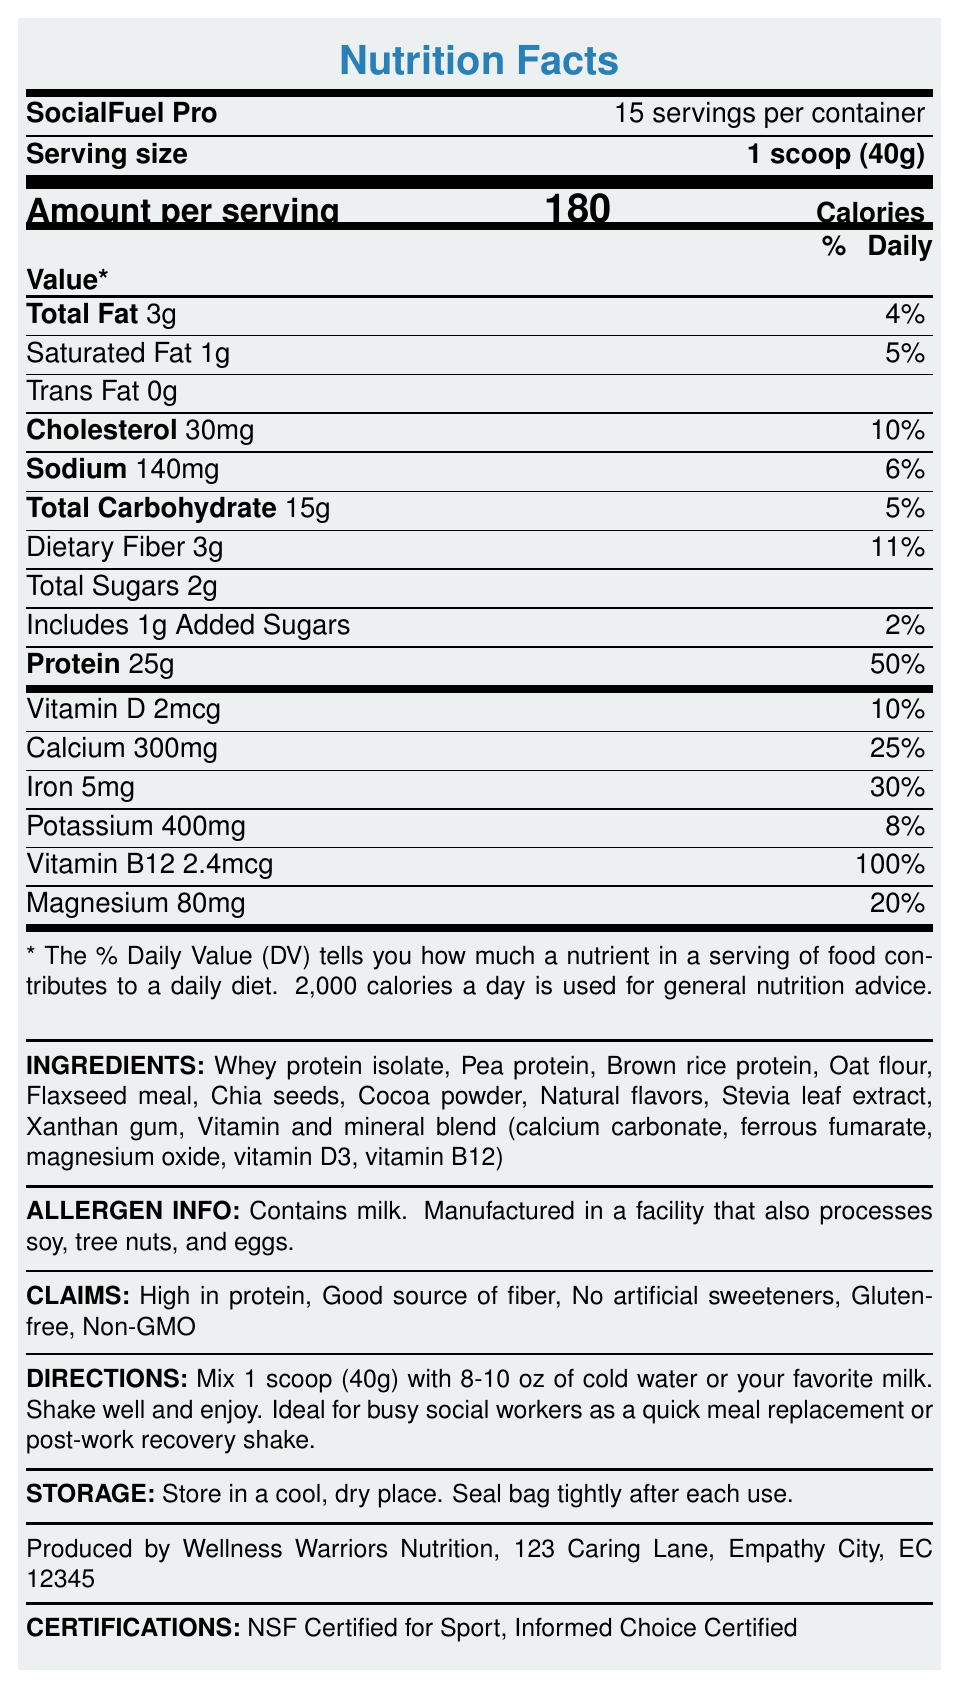What is the product name? The product name "SocialFuel Pro" is mentioned in the document under the heading "SocialFuel Pro."
Answer: SocialFuel Pro What is the serving size for this product? The serving size "1 scoop (40g)" is explicitly stated in the document.
Answer: 1 scoop (40g) How many calories are in one serving? The document lists "Calories: 180" in the section labeled "Amount per serving."
Answer: 180 What percentage of the daily value of protein is provided by one serving? The document states "Protein 25g" followed by "50%" under the "% Daily Value" column.
Answer: 50% List three proteins found in the ingredient list. The ingredients section lists "Whey protein isolate," "Pea protein," and "Brown rice protein" among other ingredients.
Answer: Whey protein isolate, Pea protein, Brown rice protein How many servings are there per container? The document mentions "15 servings per container" right beneath the product name.
Answer: 15 What is the amount of dietary fiber per serving? The document lists "Dietary Fiber 3g" under the section "Total Carbohydrate."
Answer: 3g Which vitamin in the product has the highest daily value percentage per serving? The document shows "Vitamin B12 2.4mcg" with "100%" daily value, which is the highest compared to other vitamins and minerals listed.
Answer: Vitamin B12 What are the allergens listed in the document? Contains milk. The allergens section of the document also mentions the product is manufactured in a facility that processes soy, tree nuts, and eggs.
Answer: Milk Which of the following claims does the product NOT make? A. High in protein B. Low in sodium C. Gluten-free D. Non-GMO The document lists claims including "High in protein," "Gluten-free," and "Non-GMO" but no claim about "Low in sodium."
Answer: B What mineral provides 30% of the daily value per serving? A. Calcium B. Iron C. Magnesium D. Potassium "Iron 5mg" is listed with "30%" daily value under the minerals section, while other minerals listed have different percentages.
Answer: B Is this product certified by NSF for Sport? The certifications section of the document mentions "NSF Certified for Sport."
Answer: Yes Summarize the main idea of the document. The document includes comprehensive nutritional information, ingredients, claims, and usage instructions for SocialFuel Pro, a high-protein meal replacement shake tailored for busy social workers.
Answer: The document provides the nutrition facts for a high-protein meal replacement shake called SocialFuel Pro. It details the serving size, number of servings per container, calories, macronutrient content, vitamins, and minerals, along with ingredient information, allergen info, product claims, directions for use, storage instructions, manufacturer info, and certifications. What is the specific percentage of daily value for calcium per serving? The document lists "Calcium 300mg" with a daily value of "25%."
Answer: 25% How many grams of total sugars are in one serving? The document mentions "Total Sugars 2g" under the total carbohydrate section.
Answer: 2g Who is the manufacturer of the product? The bottom of the document lists the manufacturer as "Wellness Warriors Nutrition."
Answer: Wellness Warriors Nutrition What is the vitamin and mineral blend included in the ingredients? The ingredient list includes a "Vitamin and mineral blend" specifying the components: calcium carbonate, ferrous fumarate, magnesium oxide, vitamin D3, and vitamin B12.
Answer: Calcium carbonate, ferrous fumarate, magnesium oxide, vitamin D3, vitamin B12 How should the product be stored? The storage instructions specify to "Store in a cool, dry place" and to "Seal bag tightly after each use."
Answer: Store in a cool, dry place. Seal bag tightly after each use. Does the product contain artificial sweeteners? The claims section explicitly states "No artificial sweeteners."
Answer: No What is the recommended liquid amount to mix with one scoop? The directions state to "Mix 1 scoop (40g) with 8-10 oz of cold water or your favorite milk."
Answer: 8-10 oz What percentage of daily dietary fiber does one serving provide? The document mentions "Dietary Fiber 3g" with an "11%" daily value.
Answer: 11% What is the contact address for the manufacturer? The provided "manufacturer Info" lists the address as "123 Caring Lane, Empathy City, EC 12345."
Answer: 123 Caring Lane, Empathy City, EC 12345 What is the daily value percentage for total carbohydrates per serving? The document lists "Total Carbohydrate 15g" with a daily value of "5%."
Answer: 5% Are there any tree nuts in the product? The document only states that the product is manufactured in a facility that also processes tree nuts, but it does not provide enough information to determine whether the product itself contains tree nuts.
Answer: Cannot be determined 